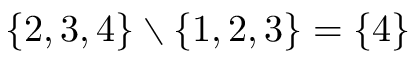Convert formula to latex. <formula><loc_0><loc_0><loc_500><loc_500>\{ 2 , 3 , 4 \} \ \{ 1 , 2 , 3 \} = \{ 4 \}</formula> 